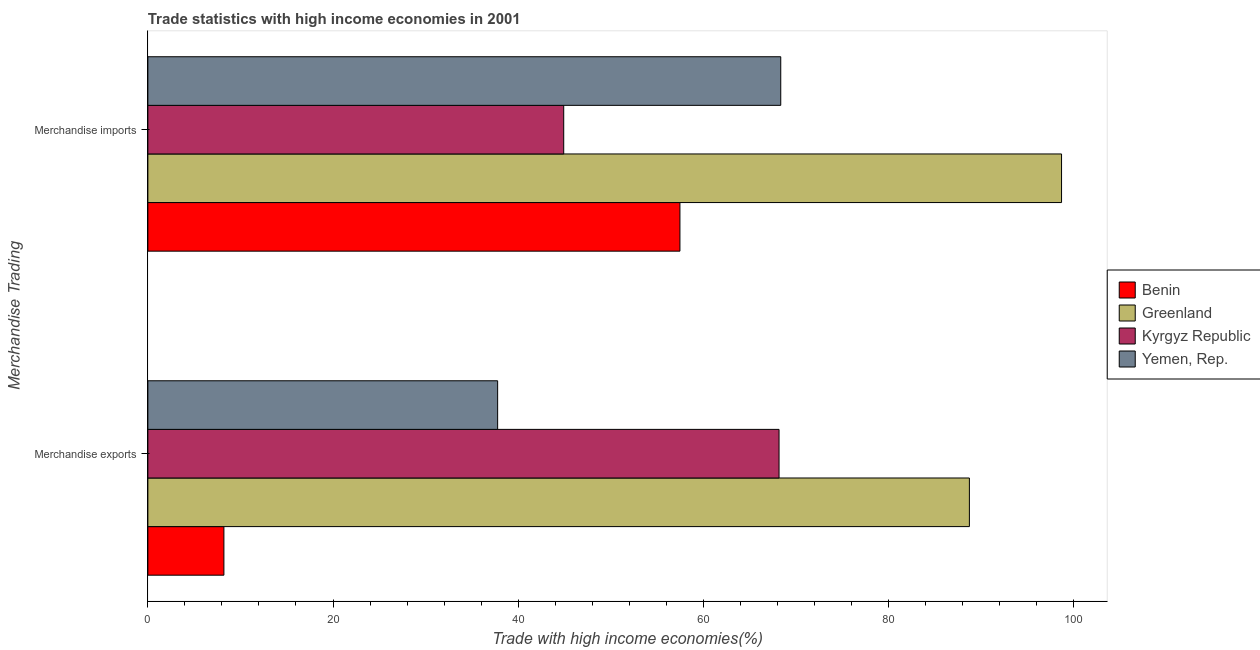How many groups of bars are there?
Your response must be concise. 2. Are the number of bars per tick equal to the number of legend labels?
Your answer should be very brief. Yes. Are the number of bars on each tick of the Y-axis equal?
Provide a short and direct response. Yes. How many bars are there on the 2nd tick from the bottom?
Give a very brief answer. 4. What is the label of the 2nd group of bars from the top?
Your answer should be very brief. Merchandise exports. What is the merchandise exports in Yemen, Rep.?
Keep it short and to the point. 37.78. Across all countries, what is the maximum merchandise exports?
Your answer should be very brief. 88.75. Across all countries, what is the minimum merchandise imports?
Keep it short and to the point. 44.92. In which country was the merchandise imports maximum?
Provide a succinct answer. Greenland. In which country was the merchandise exports minimum?
Your response must be concise. Benin. What is the total merchandise exports in the graph?
Keep it short and to the point. 202.93. What is the difference between the merchandise imports in Yemen, Rep. and that in Benin?
Give a very brief answer. 10.89. What is the difference between the merchandise imports in Yemen, Rep. and the merchandise exports in Benin?
Your response must be concise. 60.15. What is the average merchandise imports per country?
Your answer should be very brief. 67.37. What is the difference between the merchandise imports and merchandise exports in Yemen, Rep.?
Make the answer very short. 30.58. In how many countries, is the merchandise exports greater than 36 %?
Provide a short and direct response. 3. What is the ratio of the merchandise exports in Yemen, Rep. to that in Benin?
Your answer should be very brief. 4.6. Is the merchandise exports in Greenland less than that in Kyrgyz Republic?
Make the answer very short. No. What does the 4th bar from the top in Merchandise imports represents?
Your answer should be compact. Benin. What does the 4th bar from the bottom in Merchandise imports represents?
Provide a succinct answer. Yemen, Rep. How many countries are there in the graph?
Provide a short and direct response. 4. What is the title of the graph?
Offer a terse response. Trade statistics with high income economies in 2001. What is the label or title of the X-axis?
Offer a very short reply. Trade with high income economies(%). What is the label or title of the Y-axis?
Your answer should be very brief. Merchandise Trading. What is the Trade with high income economies(%) in Benin in Merchandise exports?
Your answer should be compact. 8.21. What is the Trade with high income economies(%) of Greenland in Merchandise exports?
Give a very brief answer. 88.75. What is the Trade with high income economies(%) of Kyrgyz Republic in Merchandise exports?
Make the answer very short. 68.18. What is the Trade with high income economies(%) of Yemen, Rep. in Merchandise exports?
Your answer should be compact. 37.78. What is the Trade with high income economies(%) of Benin in Merchandise imports?
Your response must be concise. 57.48. What is the Trade with high income economies(%) of Greenland in Merchandise imports?
Ensure brevity in your answer.  98.7. What is the Trade with high income economies(%) of Kyrgyz Republic in Merchandise imports?
Your answer should be compact. 44.92. What is the Trade with high income economies(%) of Yemen, Rep. in Merchandise imports?
Your response must be concise. 68.37. Across all Merchandise Trading, what is the maximum Trade with high income economies(%) in Benin?
Provide a succinct answer. 57.48. Across all Merchandise Trading, what is the maximum Trade with high income economies(%) in Greenland?
Keep it short and to the point. 98.7. Across all Merchandise Trading, what is the maximum Trade with high income economies(%) in Kyrgyz Republic?
Make the answer very short. 68.18. Across all Merchandise Trading, what is the maximum Trade with high income economies(%) of Yemen, Rep.?
Your answer should be compact. 68.37. Across all Merchandise Trading, what is the minimum Trade with high income economies(%) of Benin?
Your response must be concise. 8.21. Across all Merchandise Trading, what is the minimum Trade with high income economies(%) of Greenland?
Offer a very short reply. 88.75. Across all Merchandise Trading, what is the minimum Trade with high income economies(%) in Kyrgyz Republic?
Ensure brevity in your answer.  44.92. Across all Merchandise Trading, what is the minimum Trade with high income economies(%) in Yemen, Rep.?
Give a very brief answer. 37.78. What is the total Trade with high income economies(%) of Benin in the graph?
Provide a short and direct response. 65.69. What is the total Trade with high income economies(%) of Greenland in the graph?
Your response must be concise. 187.44. What is the total Trade with high income economies(%) of Kyrgyz Republic in the graph?
Provide a succinct answer. 113.1. What is the total Trade with high income economies(%) of Yemen, Rep. in the graph?
Your answer should be compact. 106.15. What is the difference between the Trade with high income economies(%) in Benin in Merchandise exports and that in Merchandise imports?
Ensure brevity in your answer.  -49.26. What is the difference between the Trade with high income economies(%) of Greenland in Merchandise exports and that in Merchandise imports?
Provide a succinct answer. -9.95. What is the difference between the Trade with high income economies(%) in Kyrgyz Republic in Merchandise exports and that in Merchandise imports?
Offer a terse response. 23.26. What is the difference between the Trade with high income economies(%) of Yemen, Rep. in Merchandise exports and that in Merchandise imports?
Offer a terse response. -30.58. What is the difference between the Trade with high income economies(%) of Benin in Merchandise exports and the Trade with high income economies(%) of Greenland in Merchandise imports?
Your answer should be very brief. -90.49. What is the difference between the Trade with high income economies(%) in Benin in Merchandise exports and the Trade with high income economies(%) in Kyrgyz Republic in Merchandise imports?
Offer a very short reply. -36.71. What is the difference between the Trade with high income economies(%) in Benin in Merchandise exports and the Trade with high income economies(%) in Yemen, Rep. in Merchandise imports?
Offer a terse response. -60.15. What is the difference between the Trade with high income economies(%) in Greenland in Merchandise exports and the Trade with high income economies(%) in Kyrgyz Republic in Merchandise imports?
Your answer should be very brief. 43.82. What is the difference between the Trade with high income economies(%) in Greenland in Merchandise exports and the Trade with high income economies(%) in Yemen, Rep. in Merchandise imports?
Keep it short and to the point. 20.38. What is the difference between the Trade with high income economies(%) of Kyrgyz Republic in Merchandise exports and the Trade with high income economies(%) of Yemen, Rep. in Merchandise imports?
Make the answer very short. -0.18. What is the average Trade with high income economies(%) of Benin per Merchandise Trading?
Your answer should be compact. 32.85. What is the average Trade with high income economies(%) of Greenland per Merchandise Trading?
Provide a short and direct response. 93.72. What is the average Trade with high income economies(%) of Kyrgyz Republic per Merchandise Trading?
Make the answer very short. 56.55. What is the average Trade with high income economies(%) of Yemen, Rep. per Merchandise Trading?
Your answer should be compact. 53.08. What is the difference between the Trade with high income economies(%) in Benin and Trade with high income economies(%) in Greenland in Merchandise exports?
Your answer should be compact. -80.53. What is the difference between the Trade with high income economies(%) of Benin and Trade with high income economies(%) of Kyrgyz Republic in Merchandise exports?
Provide a succinct answer. -59.97. What is the difference between the Trade with high income economies(%) of Benin and Trade with high income economies(%) of Yemen, Rep. in Merchandise exports?
Give a very brief answer. -29.57. What is the difference between the Trade with high income economies(%) in Greenland and Trade with high income economies(%) in Kyrgyz Republic in Merchandise exports?
Ensure brevity in your answer.  20.56. What is the difference between the Trade with high income economies(%) in Greenland and Trade with high income economies(%) in Yemen, Rep. in Merchandise exports?
Give a very brief answer. 50.96. What is the difference between the Trade with high income economies(%) in Kyrgyz Republic and Trade with high income economies(%) in Yemen, Rep. in Merchandise exports?
Offer a terse response. 30.4. What is the difference between the Trade with high income economies(%) of Benin and Trade with high income economies(%) of Greenland in Merchandise imports?
Your answer should be very brief. -41.22. What is the difference between the Trade with high income economies(%) in Benin and Trade with high income economies(%) in Kyrgyz Republic in Merchandise imports?
Keep it short and to the point. 12.55. What is the difference between the Trade with high income economies(%) in Benin and Trade with high income economies(%) in Yemen, Rep. in Merchandise imports?
Your answer should be compact. -10.89. What is the difference between the Trade with high income economies(%) in Greenland and Trade with high income economies(%) in Kyrgyz Republic in Merchandise imports?
Ensure brevity in your answer.  53.78. What is the difference between the Trade with high income economies(%) of Greenland and Trade with high income economies(%) of Yemen, Rep. in Merchandise imports?
Keep it short and to the point. 30.33. What is the difference between the Trade with high income economies(%) in Kyrgyz Republic and Trade with high income economies(%) in Yemen, Rep. in Merchandise imports?
Give a very brief answer. -23.44. What is the ratio of the Trade with high income economies(%) in Benin in Merchandise exports to that in Merchandise imports?
Offer a terse response. 0.14. What is the ratio of the Trade with high income economies(%) of Greenland in Merchandise exports to that in Merchandise imports?
Your answer should be compact. 0.9. What is the ratio of the Trade with high income economies(%) in Kyrgyz Republic in Merchandise exports to that in Merchandise imports?
Offer a very short reply. 1.52. What is the ratio of the Trade with high income economies(%) of Yemen, Rep. in Merchandise exports to that in Merchandise imports?
Offer a terse response. 0.55. What is the difference between the highest and the second highest Trade with high income economies(%) of Benin?
Your answer should be compact. 49.26. What is the difference between the highest and the second highest Trade with high income economies(%) in Greenland?
Keep it short and to the point. 9.95. What is the difference between the highest and the second highest Trade with high income economies(%) in Kyrgyz Republic?
Give a very brief answer. 23.26. What is the difference between the highest and the second highest Trade with high income economies(%) in Yemen, Rep.?
Your answer should be very brief. 30.58. What is the difference between the highest and the lowest Trade with high income economies(%) in Benin?
Your response must be concise. 49.26. What is the difference between the highest and the lowest Trade with high income economies(%) in Greenland?
Make the answer very short. 9.95. What is the difference between the highest and the lowest Trade with high income economies(%) in Kyrgyz Republic?
Your answer should be very brief. 23.26. What is the difference between the highest and the lowest Trade with high income economies(%) of Yemen, Rep.?
Provide a short and direct response. 30.58. 